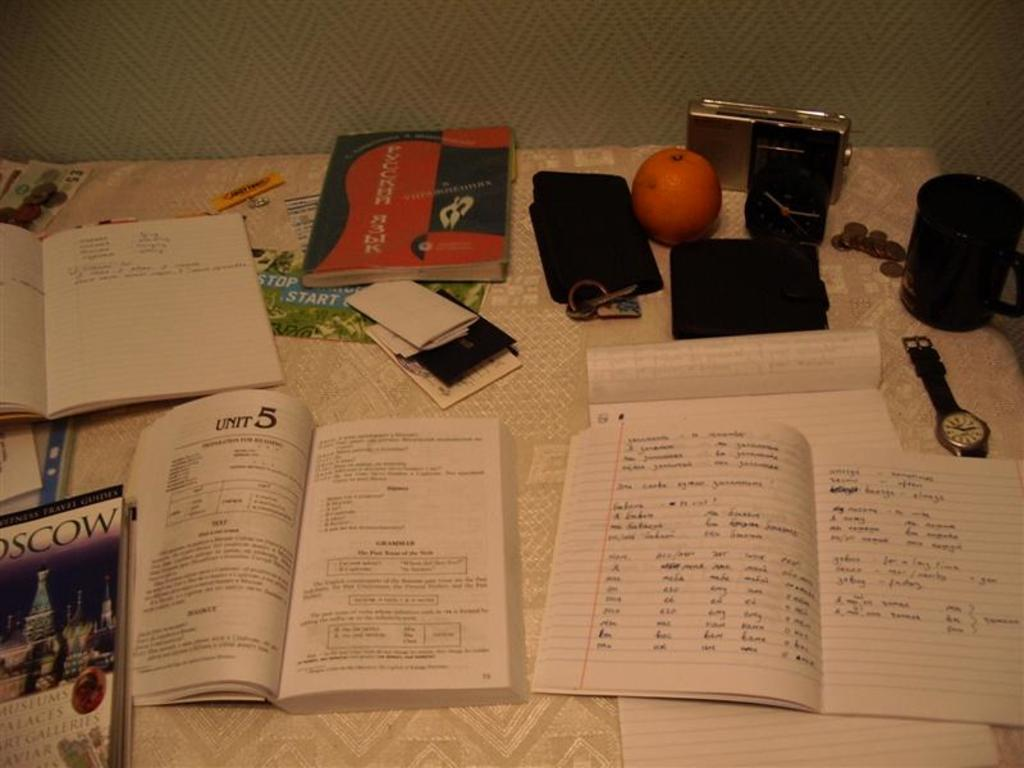<image>
Create a compact narrative representing the image presented. The book on the table is open to Unit five 